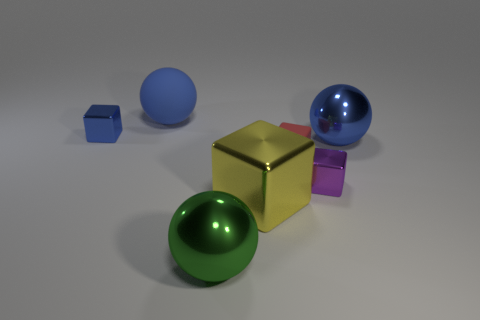Is the number of small blue things that are in front of the tiny red rubber cube greater than the number of metallic objects?
Your response must be concise. No. There is a green metallic object that is in front of the red matte cube; how many big blue balls are on the left side of it?
Your answer should be very brief. 1. Is the material of the big thing right of the large yellow shiny block the same as the big sphere that is in front of the purple cube?
Offer a very short reply. Yes. There is a small object that is the same color as the big matte object; what is it made of?
Ensure brevity in your answer.  Metal. What number of blue matte objects are the same shape as the large yellow metal object?
Give a very brief answer. 0. Is the material of the purple thing the same as the large blue object on the right side of the blue rubber sphere?
Your answer should be very brief. Yes. There is a yellow object that is the same size as the matte sphere; what is it made of?
Your response must be concise. Metal. Are there any purple shiny things of the same size as the blue matte ball?
Ensure brevity in your answer.  No. There is a blue metal thing that is the same size as the yellow metallic block; what is its shape?
Provide a succinct answer. Sphere. What number of other objects are there of the same color as the matte block?
Offer a terse response. 0. 